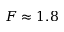<formula> <loc_0><loc_0><loc_500><loc_500>F \approx 1 . 8</formula> 